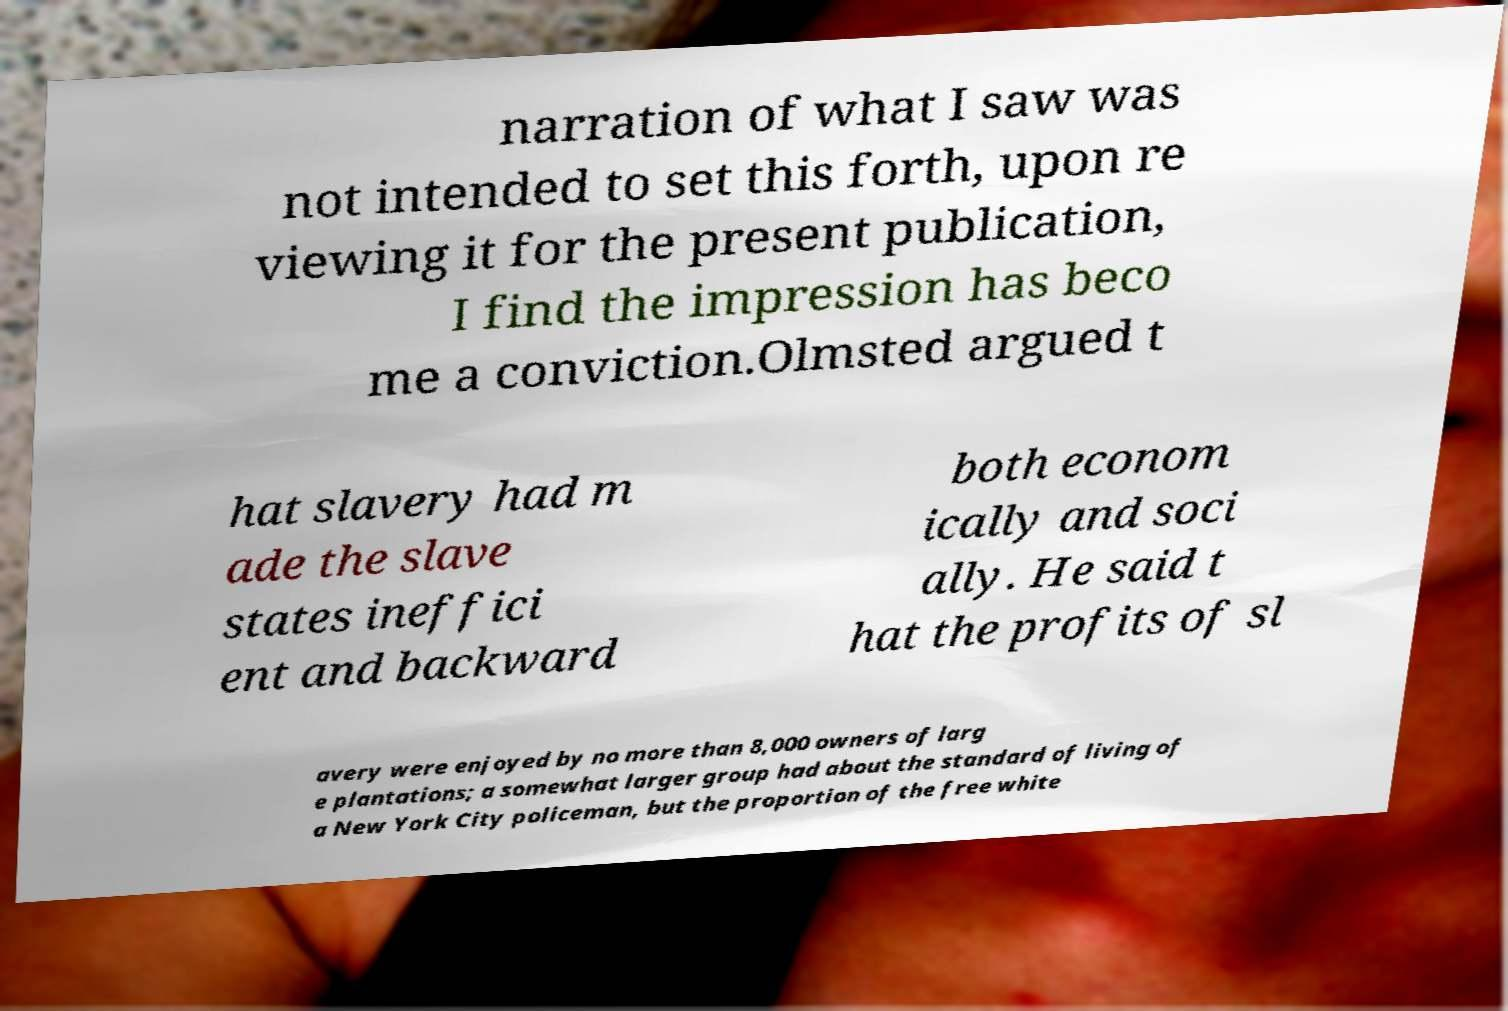Could you assist in decoding the text presented in this image and type it out clearly? narration of what I saw was not intended to set this forth, upon re viewing it for the present publication, I find the impression has beco me a conviction.Olmsted argued t hat slavery had m ade the slave states ineffici ent and backward both econom ically and soci ally. He said t hat the profits of sl avery were enjoyed by no more than 8,000 owners of larg e plantations; a somewhat larger group had about the standard of living of a New York City policeman, but the proportion of the free white 